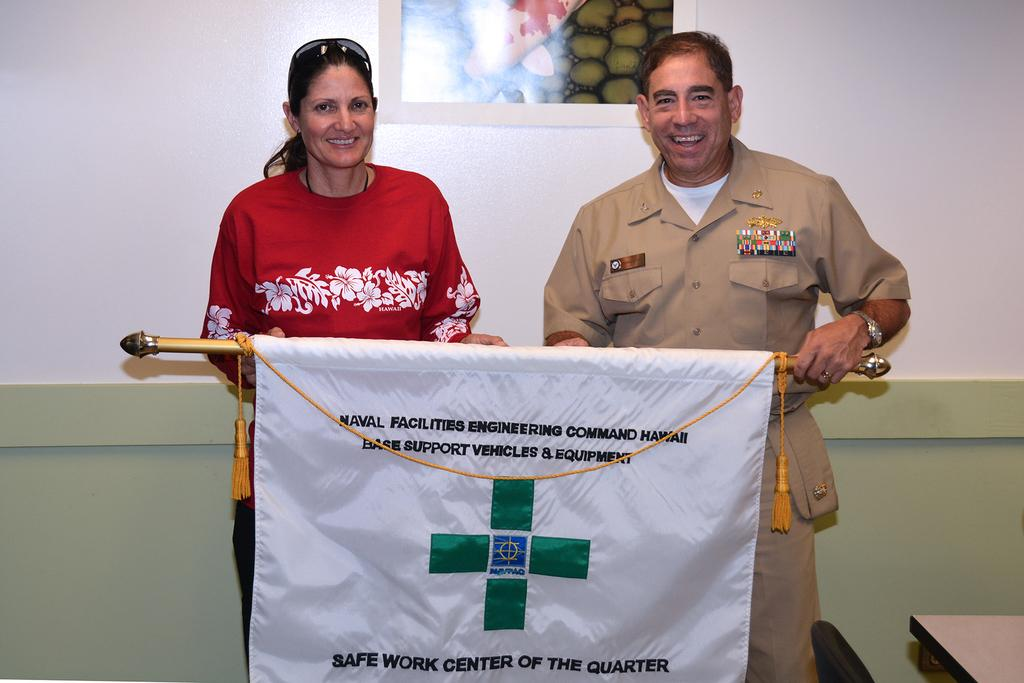Who is present in the image? There is a man and a woman in the image. What are the man and woman doing in the image? The man and woman are holding a banner. What can be seen in the background of the image? There is a painting on the wall in the background of the image. What type of pail is being used to paint the hill in the image? There is no pail or hill present in the image. 